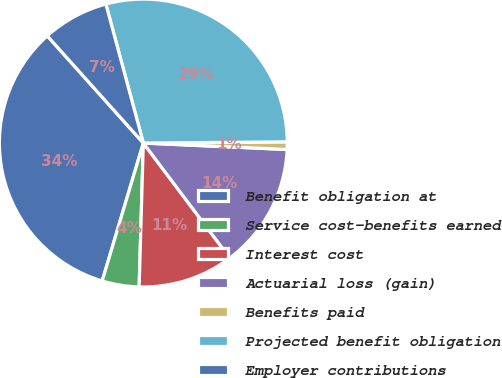<chart> <loc_0><loc_0><loc_500><loc_500><pie_chart><fcel>Benefit obligation at<fcel>Service cost-benefits earned<fcel>Interest cost<fcel>Actuarial loss (gain)<fcel>Benefits paid<fcel>Projected benefit obligation<fcel>Employer contributions<nl><fcel>33.76%<fcel>4.15%<fcel>10.73%<fcel>14.02%<fcel>0.85%<fcel>29.06%<fcel>7.44%<nl></chart> 